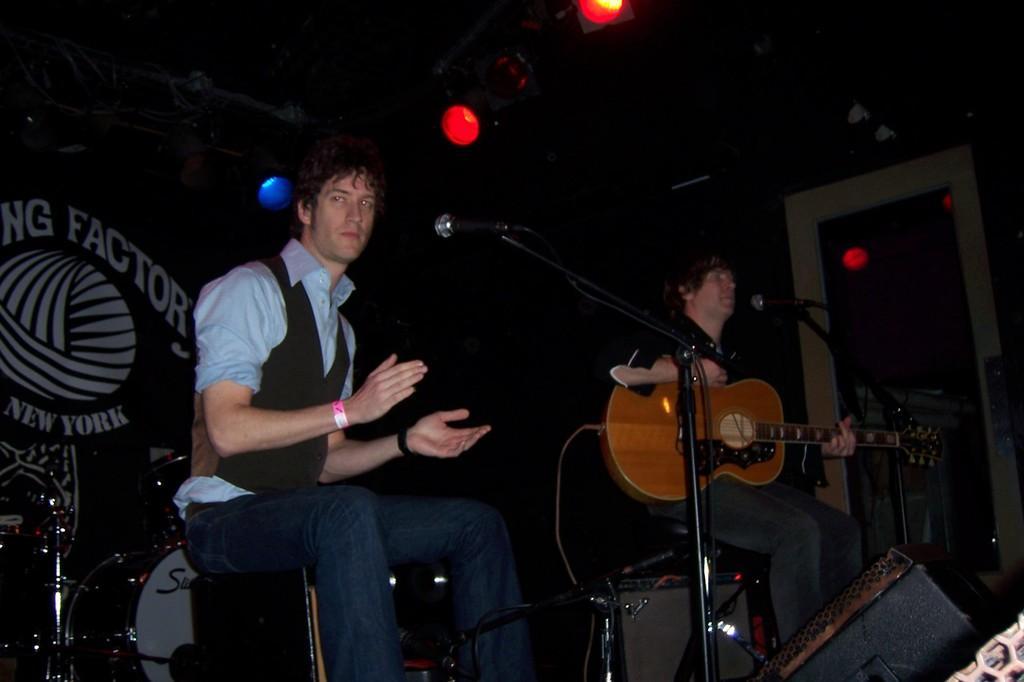Please provide a concise description of this image. This is a picture taken on a stage, the man in black shirt was holding a guitar and the other man is sitting on chair in front of these people there are microphones with stand. Behind the people there are some music instruments and a wall and there are lights on the top. 